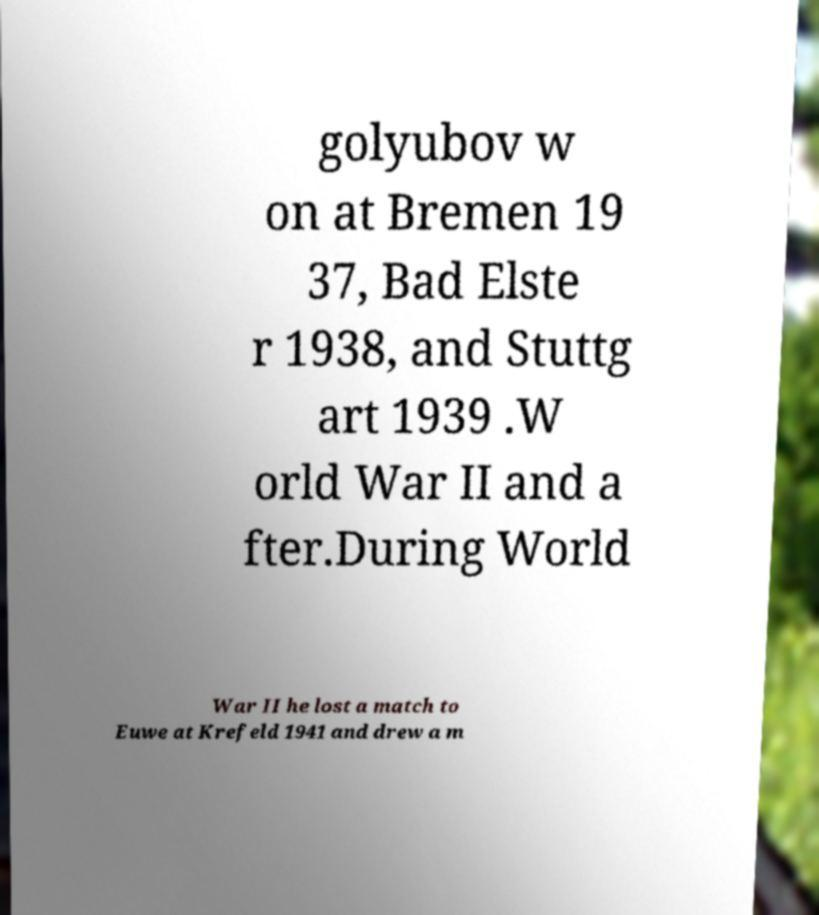Could you assist in decoding the text presented in this image and type it out clearly? golyubov w on at Bremen 19 37, Bad Elste r 1938, and Stuttg art 1939 .W orld War II and a fter.During World War II he lost a match to Euwe at Krefeld 1941 and drew a m 